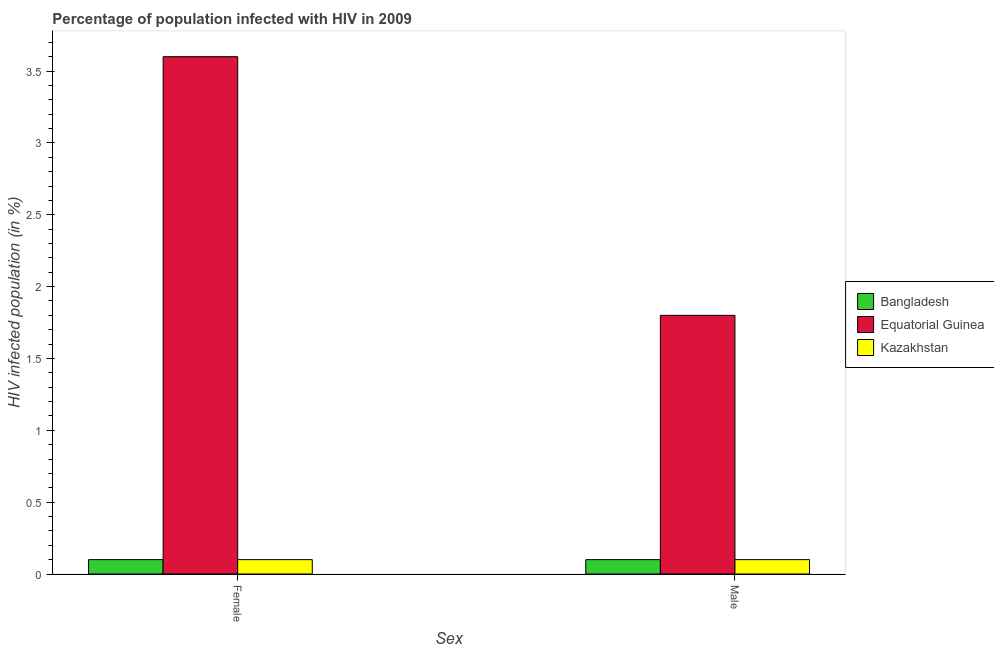How many bars are there on the 2nd tick from the left?
Keep it short and to the point. 3. What is the label of the 2nd group of bars from the left?
Make the answer very short. Male. Across all countries, what is the minimum percentage of females who are infected with hiv?
Provide a short and direct response. 0.1. In which country was the percentage of females who are infected with hiv maximum?
Provide a short and direct response. Equatorial Guinea. What is the total percentage of females who are infected with hiv in the graph?
Your answer should be compact. 3.8. What is the difference between the percentage of males who are infected with hiv in Equatorial Guinea and that in Bangladesh?
Ensure brevity in your answer.  1.7. What is the difference between the percentage of males who are infected with hiv in Kazakhstan and the percentage of females who are infected with hiv in Bangladesh?
Offer a very short reply. 0. What is the average percentage of males who are infected with hiv per country?
Provide a short and direct response. 0.67. What is the difference between the percentage of males who are infected with hiv and percentage of females who are infected with hiv in Kazakhstan?
Offer a terse response. 0. Is the percentage of males who are infected with hiv in Kazakhstan less than that in Bangladesh?
Offer a very short reply. No. In how many countries, is the percentage of females who are infected with hiv greater than the average percentage of females who are infected with hiv taken over all countries?
Provide a succinct answer. 1. What does the 3rd bar from the left in Female represents?
Offer a terse response. Kazakhstan. What does the 2nd bar from the right in Female represents?
Provide a short and direct response. Equatorial Guinea. Are all the bars in the graph horizontal?
Offer a terse response. No. How many countries are there in the graph?
Ensure brevity in your answer.  3. Does the graph contain grids?
Ensure brevity in your answer.  No. What is the title of the graph?
Give a very brief answer. Percentage of population infected with HIV in 2009. Does "Cabo Verde" appear as one of the legend labels in the graph?
Provide a short and direct response. No. What is the label or title of the X-axis?
Ensure brevity in your answer.  Sex. What is the label or title of the Y-axis?
Ensure brevity in your answer.  HIV infected population (in %). What is the HIV infected population (in %) of Bangladesh in Female?
Offer a very short reply. 0.1. What is the HIV infected population (in %) of Equatorial Guinea in Female?
Provide a short and direct response. 3.6. What is the HIV infected population (in %) of Kazakhstan in Female?
Give a very brief answer. 0.1. What is the HIV infected population (in %) in Bangladesh in Male?
Your response must be concise. 0.1. What is the HIV infected population (in %) of Equatorial Guinea in Male?
Ensure brevity in your answer.  1.8. What is the HIV infected population (in %) of Kazakhstan in Male?
Offer a terse response. 0.1. Across all Sex, what is the maximum HIV infected population (in %) of Equatorial Guinea?
Ensure brevity in your answer.  3.6. Across all Sex, what is the maximum HIV infected population (in %) in Kazakhstan?
Keep it short and to the point. 0.1. Across all Sex, what is the minimum HIV infected population (in %) of Kazakhstan?
Offer a terse response. 0.1. What is the total HIV infected population (in %) in Bangladesh in the graph?
Make the answer very short. 0.2. What is the total HIV infected population (in %) in Kazakhstan in the graph?
Offer a terse response. 0.2. What is the difference between the HIV infected population (in %) in Equatorial Guinea in Female and that in Male?
Your response must be concise. 1.8. What is the difference between the HIV infected population (in %) of Bangladesh in Female and the HIV infected population (in %) of Equatorial Guinea in Male?
Offer a very short reply. -1.7. What is the difference between the HIV infected population (in %) of Bangladesh in Female and the HIV infected population (in %) of Kazakhstan in Male?
Your response must be concise. 0. What is the difference between the HIV infected population (in %) in Equatorial Guinea in Female and the HIV infected population (in %) in Kazakhstan in Male?
Your answer should be compact. 3.5. What is the difference between the HIV infected population (in %) in Bangladesh and HIV infected population (in %) in Equatorial Guinea in Female?
Your answer should be compact. -3.5. What is the difference between the HIV infected population (in %) of Bangladesh and HIV infected population (in %) of Kazakhstan in Female?
Offer a terse response. 0. What is the difference between the HIV infected population (in %) in Equatorial Guinea and HIV infected population (in %) in Kazakhstan in Female?
Provide a succinct answer. 3.5. What is the ratio of the HIV infected population (in %) of Bangladesh in Female to that in Male?
Keep it short and to the point. 1. What is the ratio of the HIV infected population (in %) of Kazakhstan in Female to that in Male?
Give a very brief answer. 1. What is the difference between the highest and the second highest HIV infected population (in %) of Bangladesh?
Keep it short and to the point. 0. 